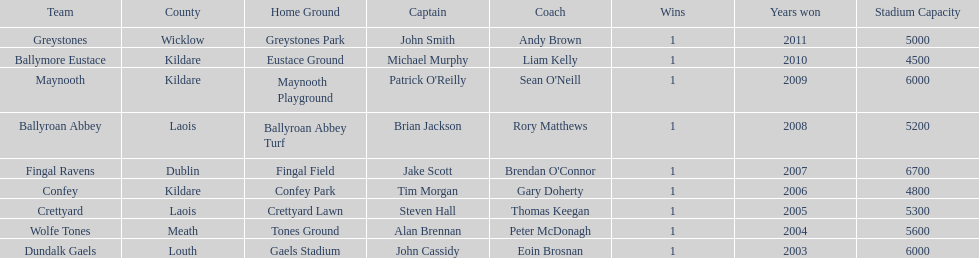What is the difference years won for crettyard and greystones 6. 